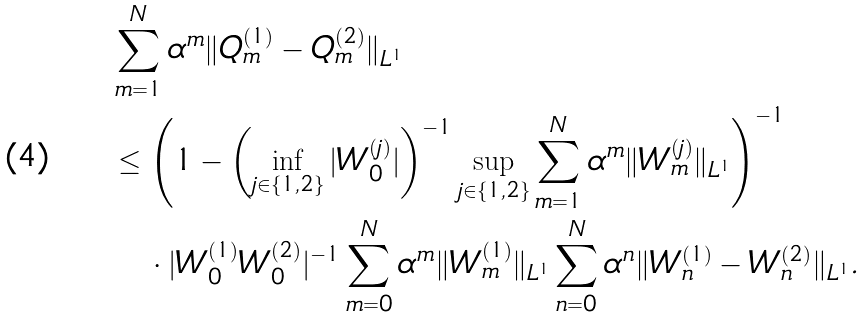<formula> <loc_0><loc_0><loc_500><loc_500>& \sum _ { m = 1 } ^ { N } \alpha ^ { m } \| Q _ { m } ^ { ( 1 ) } - Q _ { m } ^ { ( 2 ) } \| _ { L ^ { 1 } } \\ & \leq \left ( 1 - \left ( \inf _ { j \in \{ 1 , 2 \} } | W _ { 0 } ^ { ( j ) } | \right ) ^ { - 1 } \sup _ { j \in \{ 1 , 2 \} } \sum _ { m = 1 } ^ { N } \alpha ^ { m } \| W _ { m } ^ { ( j ) } \| _ { L ^ { 1 } } \right ) ^ { - 1 } \\ & \quad \cdot | W _ { 0 } ^ { ( 1 ) } W _ { 0 } ^ { ( 2 ) } | ^ { - 1 } \sum _ { m = 0 } ^ { N } \alpha ^ { m } \| W _ { m } ^ { ( 1 ) } \| _ { L ^ { 1 } } \sum _ { n = 0 } ^ { N } \alpha ^ { n } \| W _ { n } ^ { ( 1 ) } - W _ { n } ^ { ( 2 ) } \| _ { L ^ { 1 } } .</formula> 